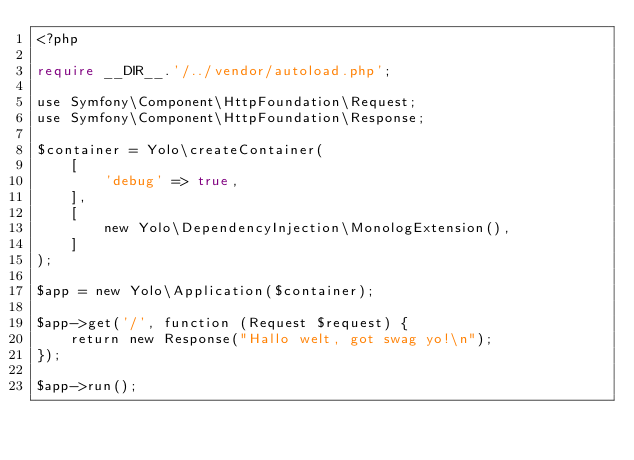<code> <loc_0><loc_0><loc_500><loc_500><_PHP_><?php

require __DIR__.'/../vendor/autoload.php';

use Symfony\Component\HttpFoundation\Request;
use Symfony\Component\HttpFoundation\Response;

$container = Yolo\createContainer(
    [
        'debug' => true,
    ],
    [
        new Yolo\DependencyInjection\MonologExtension(),
    ]
);

$app = new Yolo\Application($container);

$app->get('/', function (Request $request) {
    return new Response("Hallo welt, got swag yo!\n");
});

$app->run();
</code> 